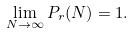Convert formula to latex. <formula><loc_0><loc_0><loc_500><loc_500>\lim _ { N \to \infty } P _ { r } ( N ) = 1 .</formula> 